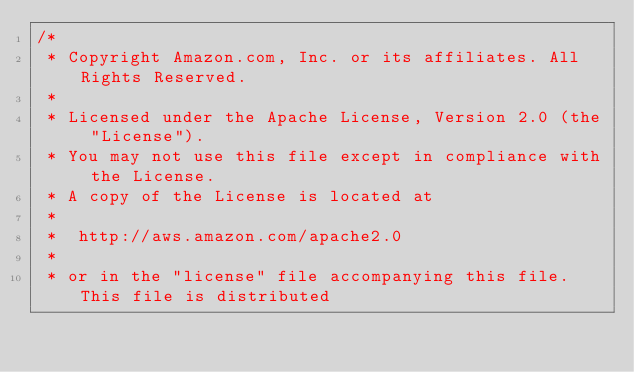Convert code to text. <code><loc_0><loc_0><loc_500><loc_500><_C#_>/*
 * Copyright Amazon.com, Inc. or its affiliates. All Rights Reserved.
 * 
 * Licensed under the Apache License, Version 2.0 (the "License").
 * You may not use this file except in compliance with the License.
 * A copy of the License is located at
 * 
 *  http://aws.amazon.com/apache2.0
 * 
 * or in the "license" file accompanying this file. This file is distributed</code> 